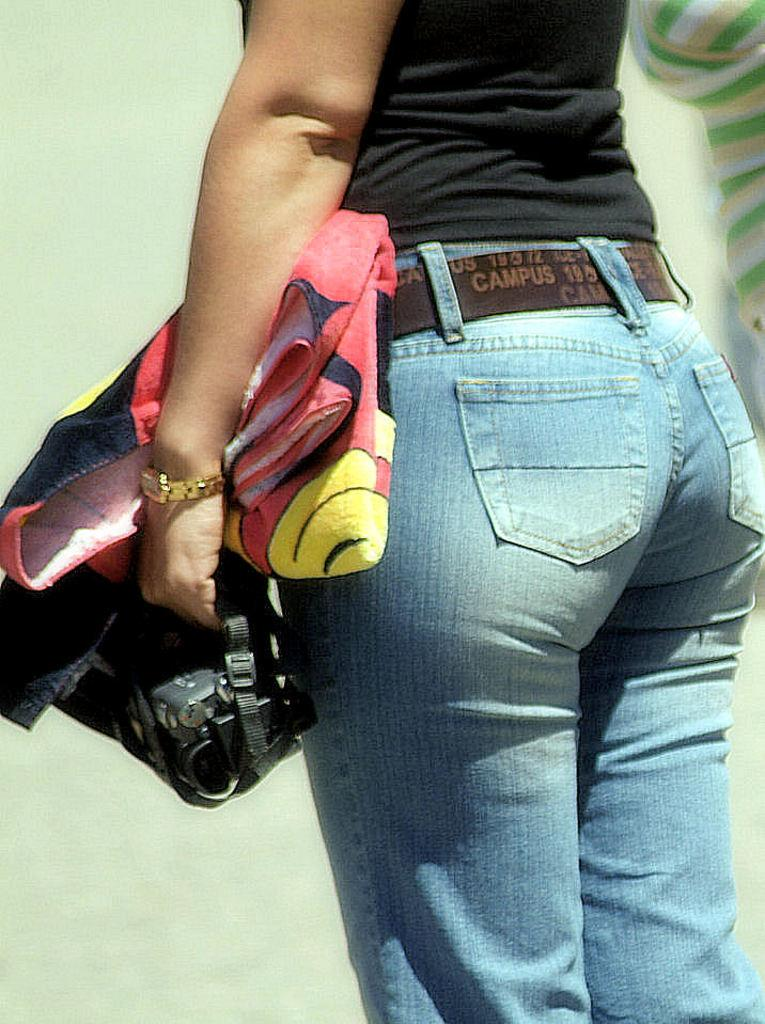What is the main subject of the image? There is a person standing in the image. What is the person holding in the image? The person is holding a cloth. Can you describe the person's surroundings? There is another person beside the first person. What type of skin condition does the person have in the image? There is no information about the person's skin condition in the image. What authority does the person in the image hold? There is no information about the person's authority in the image. 